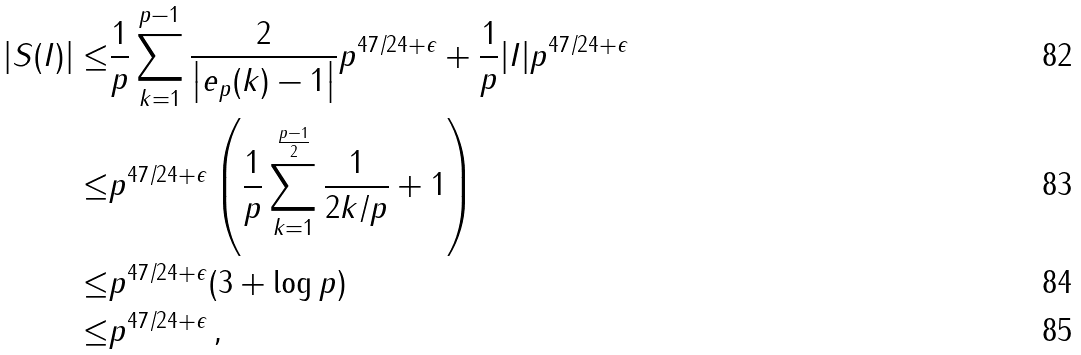Convert formula to latex. <formula><loc_0><loc_0><loc_500><loc_500>| S ( I ) | \leq & \frac { 1 } { p } \sum _ { k = 1 } ^ { p - 1 } \frac { 2 } { \left | e _ { p } ( k ) - 1 \right | } p ^ { 4 7 / 2 4 + \epsilon } + \frac { 1 } { p } | I | p ^ { 4 7 / 2 4 + \epsilon } \\ \leq & p ^ { 4 7 / 2 4 + \epsilon } \left ( \frac { 1 } { p } \sum _ { k = 1 } ^ { \frac { p - 1 } { 2 } } \frac { 1 } { 2 k / p } + 1 \right ) \\ \leq & p ^ { 4 7 / 2 4 + \epsilon } ( 3 + \log p ) \\ \leq & p ^ { 4 7 / 2 4 + \epsilon } \, ,</formula> 